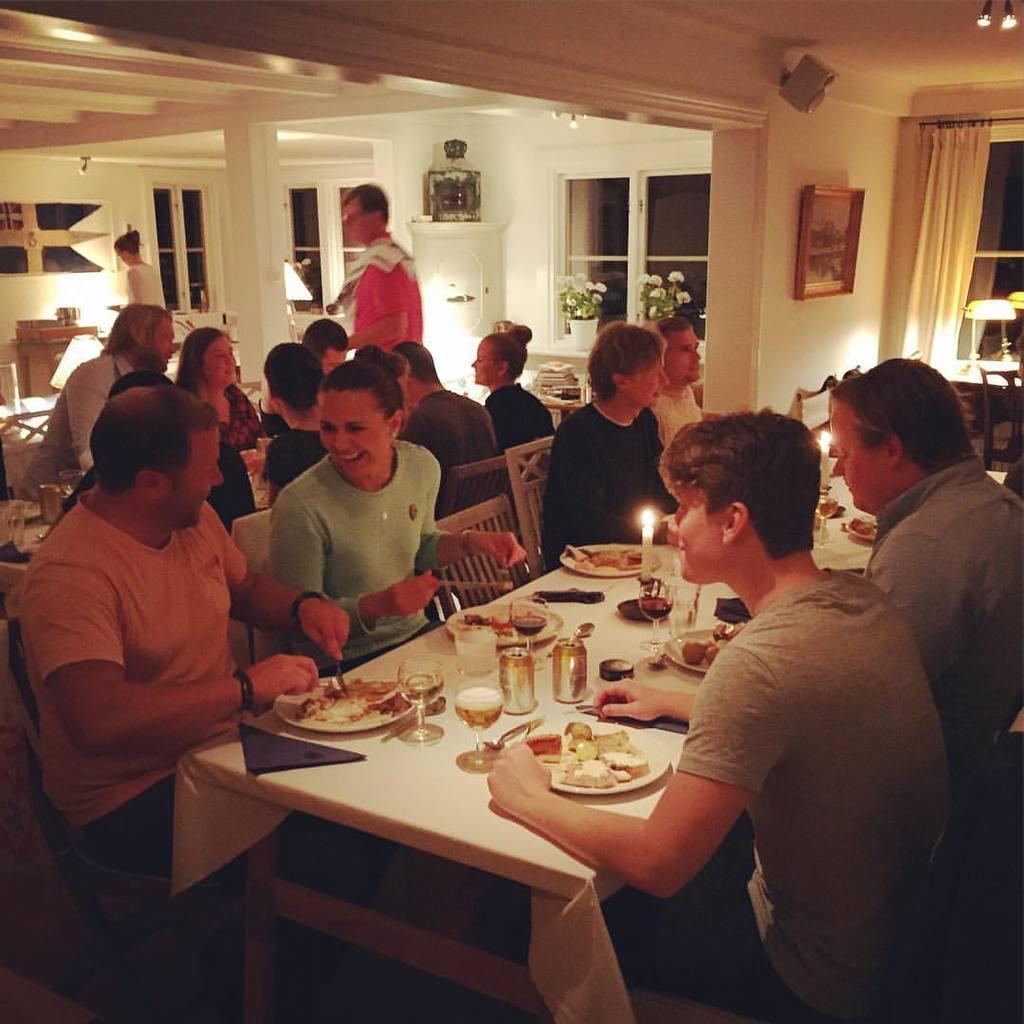Please provide a concise description of this image. in the image in the center we can see group of persons were sitting around the table. And in the front we can see three persons were smiling. On table we can see food items. Coming to the background we can see the wall,flower vase and window. 